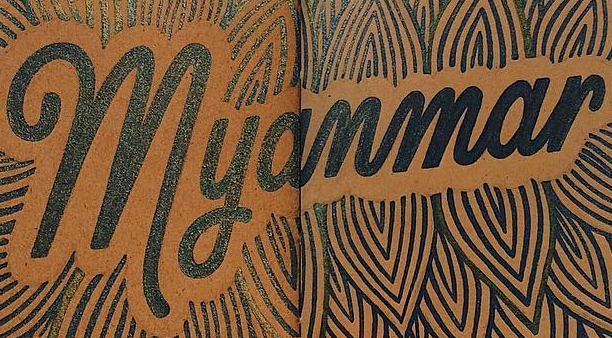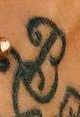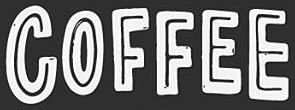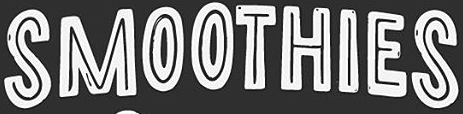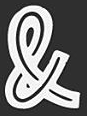Transcribe the words shown in these images in order, separated by a semicolon. Myanmar; B; COFFEE; SMOOTHIES; & 